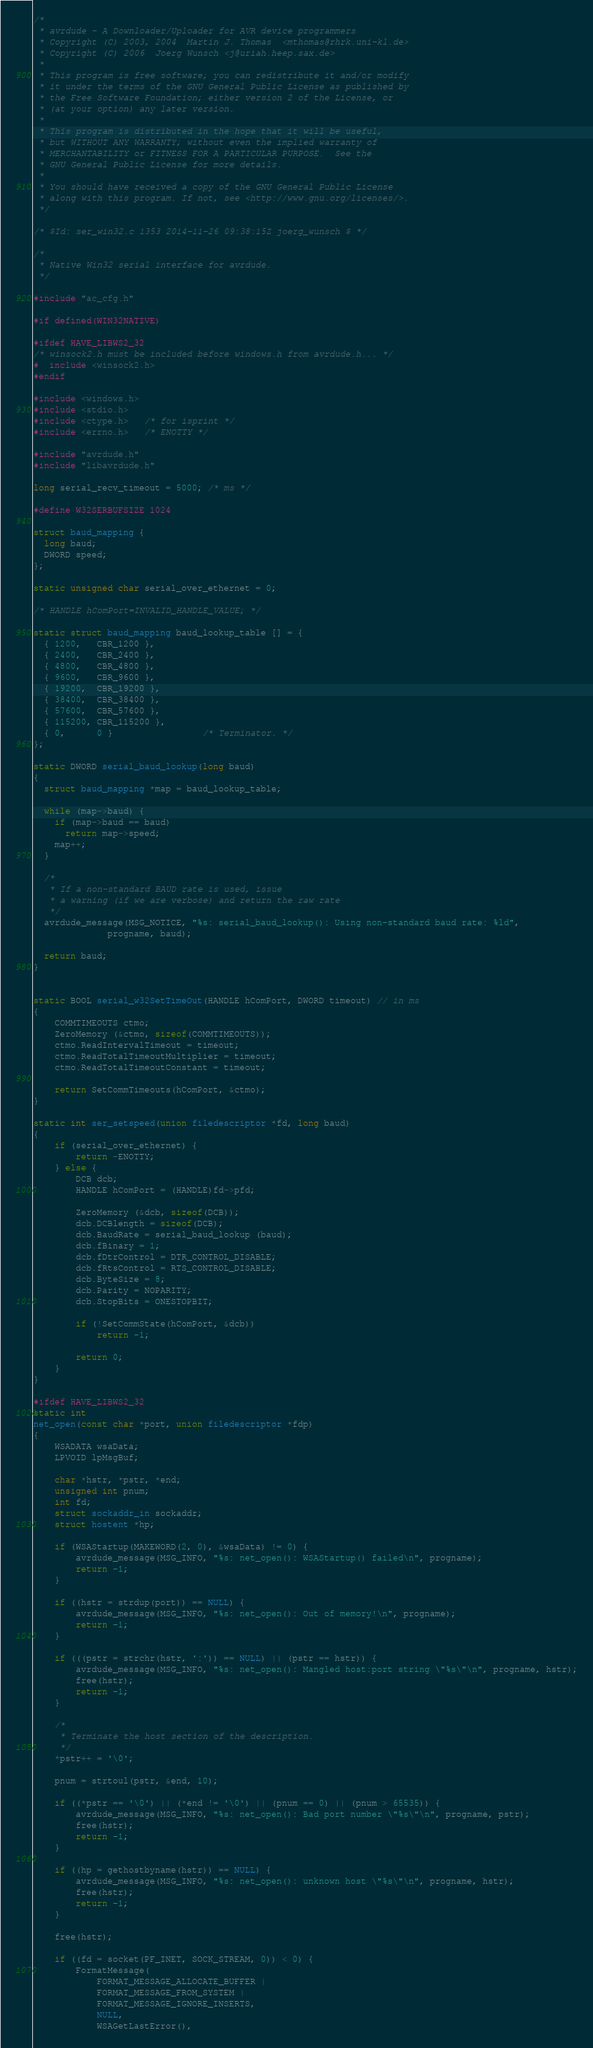Convert code to text. <code><loc_0><loc_0><loc_500><loc_500><_C_>/*
 * avrdude - A Downloader/Uploader for AVR device programmers
 * Copyright (C) 2003, 2004  Martin J. Thomas  <mthomas@rhrk.uni-kl.de>
 * Copyright (C) 2006  Joerg Wunsch <j@uriah.heep.sax.de>
 *
 * This program is free software; you can redistribute it and/or modify
 * it under the terms of the GNU General Public License as published by
 * the Free Software Foundation; either version 2 of the License, or
 * (at your option) any later version.
 *
 * This program is distributed in the hope that it will be useful,
 * but WITHOUT ANY WARRANTY; without even the implied warranty of
 * MERCHANTABILITY or FITNESS FOR A PARTICULAR PURPOSE.  See the
 * GNU General Public License for more details.
 *
 * You should have received a copy of the GNU General Public License
 * along with this program. If not, see <http://www.gnu.org/licenses/>.
 */

/* $Id: ser_win32.c 1353 2014-11-26 09:38:15Z joerg_wunsch $ */

/*
 * Native Win32 serial interface for avrdude.
 */

#include "ac_cfg.h"

#if defined(WIN32NATIVE)

#ifdef HAVE_LIBWS2_32
/* winsock2.h must be included before windows.h from avrdude.h... */
#  include <winsock2.h>
#endif

#include <windows.h>
#include <stdio.h>
#include <ctype.h>   /* for isprint */
#include <errno.h>   /* ENOTTY */

#include "avrdude.h"
#include "libavrdude.h"

long serial_recv_timeout = 5000; /* ms */

#define W32SERBUFSIZE 1024

struct baud_mapping {
  long baud;
  DWORD speed;
};

static unsigned char serial_over_ethernet = 0;

/* HANDLE hComPort=INVALID_HANDLE_VALUE; */

static struct baud_mapping baud_lookup_table [] = {
  { 1200,   CBR_1200 },
  { 2400,   CBR_2400 },
  { 4800,   CBR_4800 },
  { 9600,   CBR_9600 },
  { 19200,  CBR_19200 },
  { 38400,  CBR_38400 },
  { 57600,  CBR_57600 },
  { 115200, CBR_115200 },
  { 0,      0 }                 /* Terminator. */
};

static DWORD serial_baud_lookup(long baud)
{
  struct baud_mapping *map = baud_lookup_table;

  while (map->baud) {
    if (map->baud == baud)
      return map->speed;
    map++;
  }

  /*
   * If a non-standard BAUD rate is used, issue
   * a warning (if we are verbose) and return the raw rate
   */
  avrdude_message(MSG_NOTICE, "%s: serial_baud_lookup(): Using non-standard baud rate: %ld",
              progname, baud);

  return baud;
}


static BOOL serial_w32SetTimeOut(HANDLE hComPort, DWORD timeout) // in ms
{
	COMMTIMEOUTS ctmo;
	ZeroMemory (&ctmo, sizeof(COMMTIMEOUTS));
	ctmo.ReadIntervalTimeout = timeout;
	ctmo.ReadTotalTimeoutMultiplier = timeout;
	ctmo.ReadTotalTimeoutConstant = timeout;

	return SetCommTimeouts(hComPort, &ctmo);
}

static int ser_setspeed(union filedescriptor *fd, long baud)
{
	if (serial_over_ethernet) {
		return -ENOTTY;
	} else {
		DCB dcb;
		HANDLE hComPort = (HANDLE)fd->pfd;

		ZeroMemory (&dcb, sizeof(DCB));
		dcb.DCBlength = sizeof(DCB);
		dcb.BaudRate = serial_baud_lookup (baud);
		dcb.fBinary = 1;
		dcb.fDtrControl = DTR_CONTROL_DISABLE;
		dcb.fRtsControl = RTS_CONTROL_DISABLE;
		dcb.ByteSize = 8;
		dcb.Parity = NOPARITY;
		dcb.StopBits = ONESTOPBIT;

		if (!SetCommState(hComPort, &dcb))
			return -1;

		return 0;
	}
}

#ifdef HAVE_LIBWS2_32
static int
net_open(const char *port, union filedescriptor *fdp)
{
	WSADATA wsaData;
	LPVOID lpMsgBuf;

	char *hstr, *pstr, *end;
	unsigned int pnum;
	int fd;
	struct sockaddr_in sockaddr;
	struct hostent *hp;

	if (WSAStartup(MAKEWORD(2, 0), &wsaData) != 0) {
		avrdude_message(MSG_INFO, "%s: net_open(): WSAStartup() failed\n", progname);
		return -1;
	}

	if ((hstr = strdup(port)) == NULL) {
		avrdude_message(MSG_INFO, "%s: net_open(): Out of memory!\n", progname);
		return -1;
	}

	if (((pstr = strchr(hstr, ':')) == NULL) || (pstr == hstr)) {
		avrdude_message(MSG_INFO, "%s: net_open(): Mangled host:port string \"%s\"\n", progname, hstr);
		free(hstr);
		return -1;
	}

	/*
	 * Terminate the host section of the description.
	 */
	*pstr++ = '\0';

	pnum = strtoul(pstr, &end, 10);

	if ((*pstr == '\0') || (*end != '\0') || (pnum == 0) || (pnum > 65535)) {
		avrdude_message(MSG_INFO, "%s: net_open(): Bad port number \"%s\"\n", progname, pstr);
		free(hstr);
		return -1;
	}

	if ((hp = gethostbyname(hstr)) == NULL) {
		avrdude_message(MSG_INFO, "%s: net_open(): unknown host \"%s\"\n", progname, hstr);
		free(hstr);
		return -1;
	}

	free(hstr);

	if ((fd = socket(PF_INET, SOCK_STREAM, 0)) < 0) {
		FormatMessage(
			FORMAT_MESSAGE_ALLOCATE_BUFFER |
			FORMAT_MESSAGE_FROM_SYSTEM |
			FORMAT_MESSAGE_IGNORE_INSERTS,
			NULL,
			WSAGetLastError(),</code> 